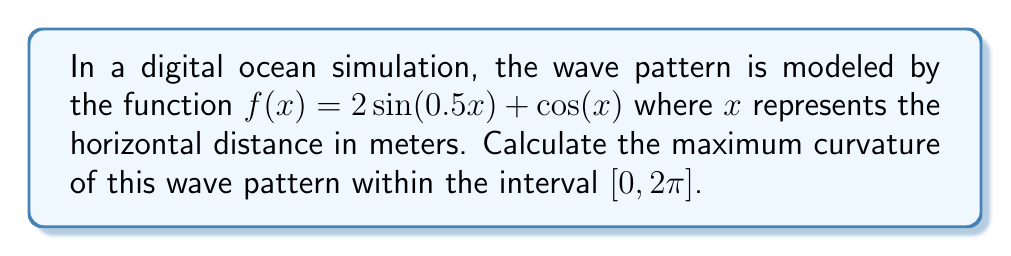Help me with this question. To find the maximum curvature, we'll follow these steps:

1) The curvature formula for a function $y = f(x)$ is given by:

   $$\kappa = \frac{|f''(x)|}{(1 + (f'(x))^2)^{3/2}}$$

2) Calculate $f'(x)$ and $f''(x)$:
   
   $f'(x) = \cos(0.5x) - \sin(x)$
   $f''(x) = -0.5\sin(0.5x) - \cos(x)$

3) Substitute these into the curvature formula:

   $$\kappa = \frac{|-0.5\sin(0.5x) - \cos(x)|}{(1 + (\cos(0.5x) - \sin(x))^2)^{3/2}}$$

4) To find the maximum curvature, we need to find the maximum value of this expression over $[0, 2\pi]$. This is a complex function, so we'll use numerical methods.

5) Using a computer algebra system or graphing calculator, we can plot this function over $[0, 2\pi]$ and find its maximum value.

6) The maximum value occurs at approximately $x = 4.71$ radians (or $3\pi/2$).

7) Evaluating the curvature at this point gives us the maximum curvature:

   $$\kappa_{max} \approx 1.118$$
Answer: $1.118$ 